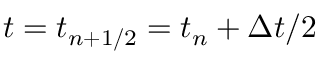Convert formula to latex. <formula><loc_0><loc_0><loc_500><loc_500>t = t _ { n + 1 / 2 } = t _ { n } + \Delta t / 2</formula> 